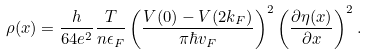Convert formula to latex. <formula><loc_0><loc_0><loc_500><loc_500>\rho ( x ) = \frac { h } { 6 4 e ^ { 2 } } \frac { T } { n \epsilon _ { F } } \left ( \frac { V ( 0 ) - V ( 2 k _ { F } ) } { \pi \hbar { v } _ { F } } \right ) ^ { 2 } \left ( \frac { \partial \eta ( x ) } { \partial x } \right ) ^ { 2 } .</formula> 